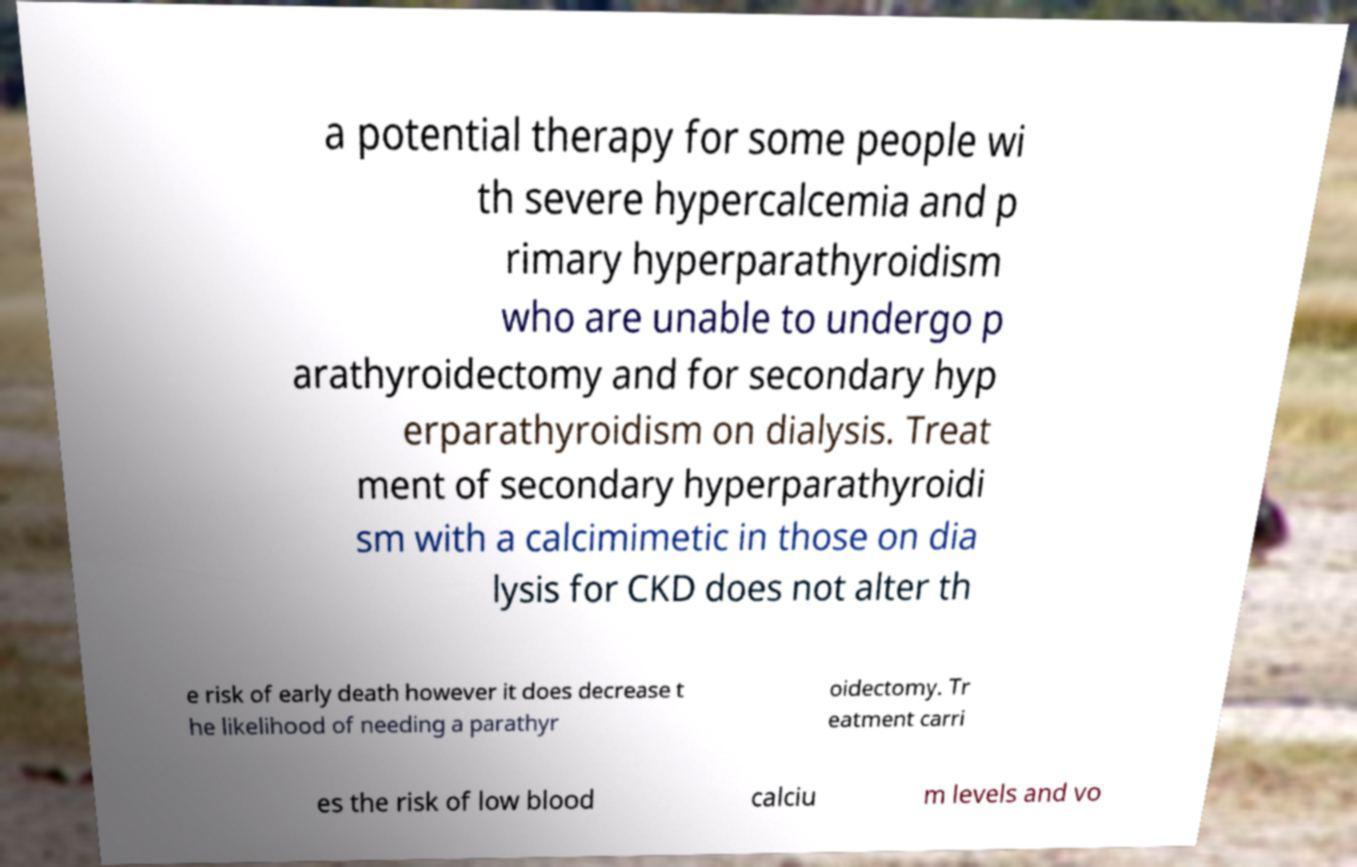There's text embedded in this image that I need extracted. Can you transcribe it verbatim? a potential therapy for some people wi th severe hypercalcemia and p rimary hyperparathyroidism who are unable to undergo p arathyroidectomy and for secondary hyp erparathyroidism on dialysis. Treat ment of secondary hyperparathyroidi sm with a calcimimetic in those on dia lysis for CKD does not alter th e risk of early death however it does decrease t he likelihood of needing a parathyr oidectomy. Tr eatment carri es the risk of low blood calciu m levels and vo 